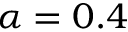<formula> <loc_0><loc_0><loc_500><loc_500>\alpha = 0 . 4</formula> 